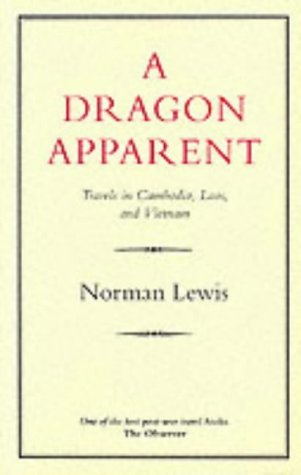Is this book related to Travel? Yes, absolutely. 'A Dragon Apparent' is fundamentally a travel book, documenting the intriguing regions of Cambodia, Laos, and Vietnam. 